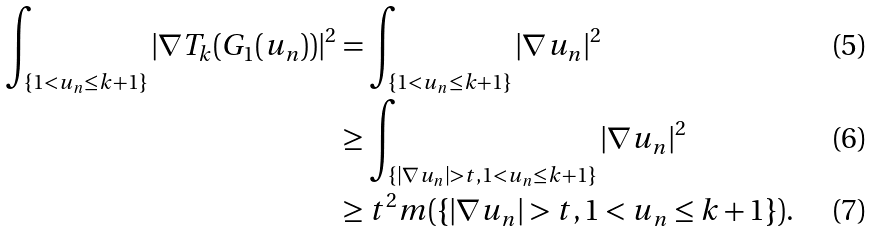<formula> <loc_0><loc_0><loc_500><loc_500>\int _ { \left \{ 1 < u _ { n } \leq k + 1 \right \} } | \nabla T _ { k } ( G _ { 1 } ( u _ { n } ) ) | ^ { 2 } & = \int _ { \left \{ 1 < u _ { n } \leq k + 1 \right \} } | \nabla u _ { n } | ^ { 2 } \\ & \geq \int _ { \left \{ | \nabla u _ { n } | > t , 1 < u _ { n } \leq k + 1 \right \} } | \nabla u _ { n } | ^ { 2 } \\ & \geq t ^ { 2 } m ( \{ | \nabla u _ { n } | > t , 1 < u _ { n } \leq k + 1 \} ) .</formula> 